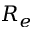<formula> <loc_0><loc_0><loc_500><loc_500>R _ { e }</formula> 